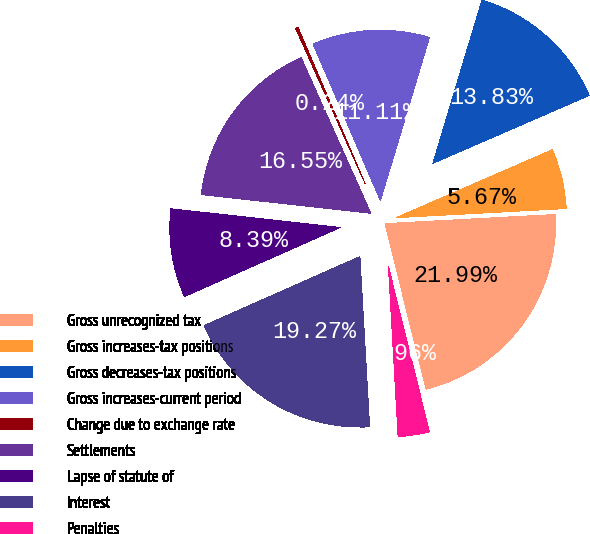<chart> <loc_0><loc_0><loc_500><loc_500><pie_chart><fcel>Gross unrecognized tax<fcel>Gross increases-tax positions<fcel>Gross decreases-tax positions<fcel>Gross increases-current period<fcel>Change due to exchange rate<fcel>Settlements<fcel>Lapse of statute of<fcel>Interest<fcel>Penalties<nl><fcel>21.99%<fcel>5.67%<fcel>13.83%<fcel>11.11%<fcel>0.24%<fcel>16.55%<fcel>8.39%<fcel>19.27%<fcel>2.96%<nl></chart> 